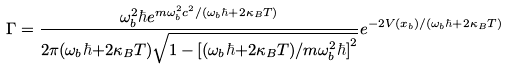Convert formula to latex. <formula><loc_0><loc_0><loc_500><loc_500>\Gamma = \frac { \omega ^ { 2 } _ { b } \hbar { e } ^ { m \omega _ { b } ^ { 2 } c ^ { 2 } / ( \omega _ { b } \hbar { + } 2 \kappa _ { B } T ) } } { 2 \pi ( \omega _ { b } \hbar { + } 2 \kappa _ { B } T ) \sqrt { 1 - [ ( \omega _ { b } \hbar { + } 2 \kappa _ { B } T ) / m \omega ^ { 2 } _ { b } \hbar { ] } ^ { 2 } } } e ^ { - 2 V ( x _ { b } ) / ( \omega _ { b } \hbar { + } 2 \kappa _ { B } T ) }</formula> 